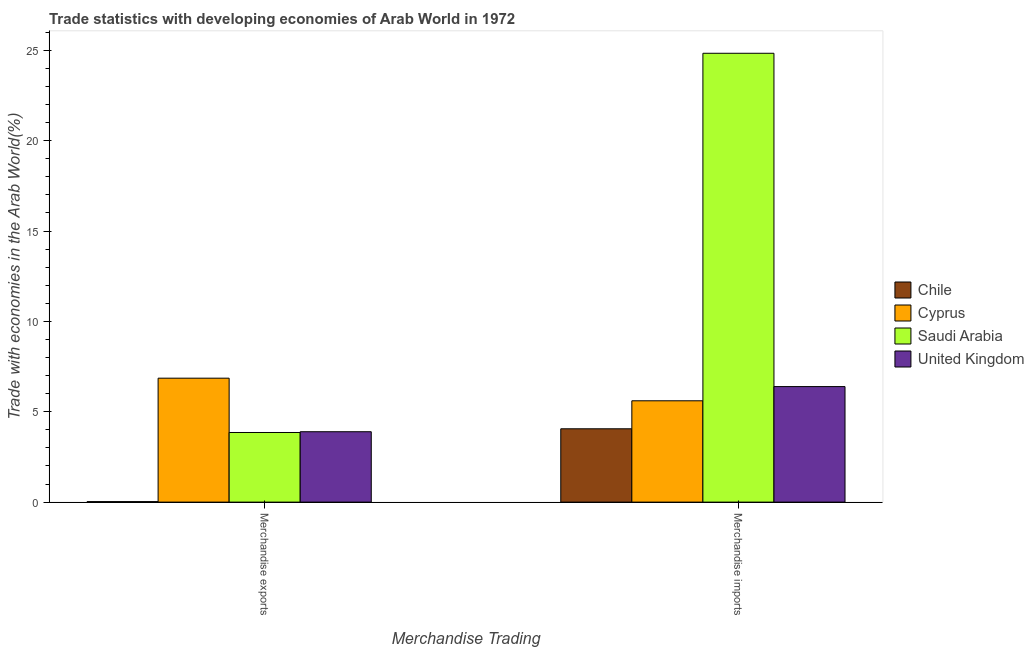How many different coloured bars are there?
Your response must be concise. 4. How many groups of bars are there?
Your answer should be very brief. 2. Are the number of bars per tick equal to the number of legend labels?
Your answer should be compact. Yes. Are the number of bars on each tick of the X-axis equal?
Your answer should be very brief. Yes. What is the label of the 1st group of bars from the left?
Provide a short and direct response. Merchandise exports. What is the merchandise imports in Chile?
Your answer should be very brief. 4.06. Across all countries, what is the maximum merchandise exports?
Your answer should be compact. 6.86. Across all countries, what is the minimum merchandise exports?
Give a very brief answer. 0.03. In which country was the merchandise imports maximum?
Your answer should be very brief. Saudi Arabia. In which country was the merchandise imports minimum?
Your response must be concise. Chile. What is the total merchandise exports in the graph?
Your answer should be compact. 14.63. What is the difference between the merchandise imports in Saudi Arabia and that in Cyprus?
Make the answer very short. 19.23. What is the difference between the merchandise exports in Saudi Arabia and the merchandise imports in Cyprus?
Offer a terse response. -1.75. What is the average merchandise imports per country?
Provide a succinct answer. 10.22. What is the difference between the merchandise imports and merchandise exports in United Kingdom?
Ensure brevity in your answer.  2.5. In how many countries, is the merchandise exports greater than 1 %?
Keep it short and to the point. 3. What is the ratio of the merchandise exports in Saudi Arabia to that in Cyprus?
Provide a succinct answer. 0.56. In how many countries, is the merchandise exports greater than the average merchandise exports taken over all countries?
Provide a succinct answer. 3. What does the 2nd bar from the left in Merchandise imports represents?
Provide a short and direct response. Cyprus. What does the 3rd bar from the right in Merchandise exports represents?
Provide a succinct answer. Cyprus. Are all the bars in the graph horizontal?
Offer a terse response. No. What is the difference between two consecutive major ticks on the Y-axis?
Your answer should be compact. 5. Are the values on the major ticks of Y-axis written in scientific E-notation?
Offer a very short reply. No. Does the graph contain any zero values?
Provide a succinct answer. No. Where does the legend appear in the graph?
Make the answer very short. Center right. How many legend labels are there?
Offer a very short reply. 4. What is the title of the graph?
Provide a succinct answer. Trade statistics with developing economies of Arab World in 1972. What is the label or title of the X-axis?
Offer a terse response. Merchandise Trading. What is the label or title of the Y-axis?
Your answer should be very brief. Trade with economies in the Arab World(%). What is the Trade with economies in the Arab World(%) in Chile in Merchandise exports?
Offer a very short reply. 0.03. What is the Trade with economies in the Arab World(%) of Cyprus in Merchandise exports?
Offer a terse response. 6.86. What is the Trade with economies in the Arab World(%) in Saudi Arabia in Merchandise exports?
Provide a short and direct response. 3.85. What is the Trade with economies in the Arab World(%) of United Kingdom in Merchandise exports?
Your response must be concise. 3.89. What is the Trade with economies in the Arab World(%) in Chile in Merchandise imports?
Offer a very short reply. 4.06. What is the Trade with economies in the Arab World(%) in Cyprus in Merchandise imports?
Give a very brief answer. 5.61. What is the Trade with economies in the Arab World(%) of Saudi Arabia in Merchandise imports?
Provide a succinct answer. 24.83. What is the Trade with economies in the Arab World(%) in United Kingdom in Merchandise imports?
Provide a succinct answer. 6.39. Across all Merchandise Trading, what is the maximum Trade with economies in the Arab World(%) in Chile?
Your answer should be very brief. 4.06. Across all Merchandise Trading, what is the maximum Trade with economies in the Arab World(%) in Cyprus?
Give a very brief answer. 6.86. Across all Merchandise Trading, what is the maximum Trade with economies in the Arab World(%) of Saudi Arabia?
Make the answer very short. 24.83. Across all Merchandise Trading, what is the maximum Trade with economies in the Arab World(%) of United Kingdom?
Offer a terse response. 6.39. Across all Merchandise Trading, what is the minimum Trade with economies in the Arab World(%) in Chile?
Give a very brief answer. 0.03. Across all Merchandise Trading, what is the minimum Trade with economies in the Arab World(%) in Cyprus?
Provide a succinct answer. 5.61. Across all Merchandise Trading, what is the minimum Trade with economies in the Arab World(%) of Saudi Arabia?
Your answer should be compact. 3.85. Across all Merchandise Trading, what is the minimum Trade with economies in the Arab World(%) of United Kingdom?
Offer a very short reply. 3.89. What is the total Trade with economies in the Arab World(%) in Chile in the graph?
Keep it short and to the point. 4.09. What is the total Trade with economies in the Arab World(%) of Cyprus in the graph?
Provide a succinct answer. 12.46. What is the total Trade with economies in the Arab World(%) in Saudi Arabia in the graph?
Keep it short and to the point. 28.69. What is the total Trade with economies in the Arab World(%) of United Kingdom in the graph?
Your response must be concise. 10.29. What is the difference between the Trade with economies in the Arab World(%) in Chile in Merchandise exports and that in Merchandise imports?
Offer a very short reply. -4.03. What is the difference between the Trade with economies in the Arab World(%) in Cyprus in Merchandise exports and that in Merchandise imports?
Ensure brevity in your answer.  1.25. What is the difference between the Trade with economies in the Arab World(%) of Saudi Arabia in Merchandise exports and that in Merchandise imports?
Offer a terse response. -20.98. What is the difference between the Trade with economies in the Arab World(%) of United Kingdom in Merchandise exports and that in Merchandise imports?
Your response must be concise. -2.5. What is the difference between the Trade with economies in the Arab World(%) in Chile in Merchandise exports and the Trade with economies in the Arab World(%) in Cyprus in Merchandise imports?
Provide a succinct answer. -5.58. What is the difference between the Trade with economies in the Arab World(%) in Chile in Merchandise exports and the Trade with economies in the Arab World(%) in Saudi Arabia in Merchandise imports?
Your answer should be compact. -24.81. What is the difference between the Trade with economies in the Arab World(%) of Chile in Merchandise exports and the Trade with economies in the Arab World(%) of United Kingdom in Merchandise imports?
Your response must be concise. -6.36. What is the difference between the Trade with economies in the Arab World(%) of Cyprus in Merchandise exports and the Trade with economies in the Arab World(%) of Saudi Arabia in Merchandise imports?
Keep it short and to the point. -17.98. What is the difference between the Trade with economies in the Arab World(%) of Cyprus in Merchandise exports and the Trade with economies in the Arab World(%) of United Kingdom in Merchandise imports?
Give a very brief answer. 0.46. What is the difference between the Trade with economies in the Arab World(%) in Saudi Arabia in Merchandise exports and the Trade with economies in the Arab World(%) in United Kingdom in Merchandise imports?
Your response must be concise. -2.54. What is the average Trade with economies in the Arab World(%) of Chile per Merchandise Trading?
Ensure brevity in your answer.  2.04. What is the average Trade with economies in the Arab World(%) in Cyprus per Merchandise Trading?
Ensure brevity in your answer.  6.23. What is the average Trade with economies in the Arab World(%) of Saudi Arabia per Merchandise Trading?
Provide a short and direct response. 14.34. What is the average Trade with economies in the Arab World(%) in United Kingdom per Merchandise Trading?
Give a very brief answer. 5.14. What is the difference between the Trade with economies in the Arab World(%) in Chile and Trade with economies in the Arab World(%) in Cyprus in Merchandise exports?
Give a very brief answer. -6.83. What is the difference between the Trade with economies in the Arab World(%) of Chile and Trade with economies in the Arab World(%) of Saudi Arabia in Merchandise exports?
Provide a succinct answer. -3.82. What is the difference between the Trade with economies in the Arab World(%) of Chile and Trade with economies in the Arab World(%) of United Kingdom in Merchandise exports?
Your answer should be compact. -3.87. What is the difference between the Trade with economies in the Arab World(%) in Cyprus and Trade with economies in the Arab World(%) in Saudi Arabia in Merchandise exports?
Your answer should be very brief. 3. What is the difference between the Trade with economies in the Arab World(%) of Cyprus and Trade with economies in the Arab World(%) of United Kingdom in Merchandise exports?
Ensure brevity in your answer.  2.96. What is the difference between the Trade with economies in the Arab World(%) in Saudi Arabia and Trade with economies in the Arab World(%) in United Kingdom in Merchandise exports?
Your answer should be very brief. -0.04. What is the difference between the Trade with economies in the Arab World(%) in Chile and Trade with economies in the Arab World(%) in Cyprus in Merchandise imports?
Ensure brevity in your answer.  -1.55. What is the difference between the Trade with economies in the Arab World(%) of Chile and Trade with economies in the Arab World(%) of Saudi Arabia in Merchandise imports?
Provide a succinct answer. -20.78. What is the difference between the Trade with economies in the Arab World(%) of Chile and Trade with economies in the Arab World(%) of United Kingdom in Merchandise imports?
Your answer should be compact. -2.33. What is the difference between the Trade with economies in the Arab World(%) of Cyprus and Trade with economies in the Arab World(%) of Saudi Arabia in Merchandise imports?
Give a very brief answer. -19.23. What is the difference between the Trade with economies in the Arab World(%) in Cyprus and Trade with economies in the Arab World(%) in United Kingdom in Merchandise imports?
Your response must be concise. -0.79. What is the difference between the Trade with economies in the Arab World(%) of Saudi Arabia and Trade with economies in the Arab World(%) of United Kingdom in Merchandise imports?
Keep it short and to the point. 18.44. What is the ratio of the Trade with economies in the Arab World(%) of Chile in Merchandise exports to that in Merchandise imports?
Give a very brief answer. 0.01. What is the ratio of the Trade with economies in the Arab World(%) in Cyprus in Merchandise exports to that in Merchandise imports?
Offer a very short reply. 1.22. What is the ratio of the Trade with economies in the Arab World(%) in Saudi Arabia in Merchandise exports to that in Merchandise imports?
Give a very brief answer. 0.16. What is the ratio of the Trade with economies in the Arab World(%) in United Kingdom in Merchandise exports to that in Merchandise imports?
Give a very brief answer. 0.61. What is the difference between the highest and the second highest Trade with economies in the Arab World(%) in Chile?
Ensure brevity in your answer.  4.03. What is the difference between the highest and the second highest Trade with economies in the Arab World(%) in Cyprus?
Ensure brevity in your answer.  1.25. What is the difference between the highest and the second highest Trade with economies in the Arab World(%) of Saudi Arabia?
Offer a very short reply. 20.98. What is the difference between the highest and the second highest Trade with economies in the Arab World(%) in United Kingdom?
Give a very brief answer. 2.5. What is the difference between the highest and the lowest Trade with economies in the Arab World(%) of Chile?
Keep it short and to the point. 4.03. What is the difference between the highest and the lowest Trade with economies in the Arab World(%) in Cyprus?
Make the answer very short. 1.25. What is the difference between the highest and the lowest Trade with economies in the Arab World(%) of Saudi Arabia?
Your answer should be compact. 20.98. What is the difference between the highest and the lowest Trade with economies in the Arab World(%) of United Kingdom?
Your answer should be compact. 2.5. 